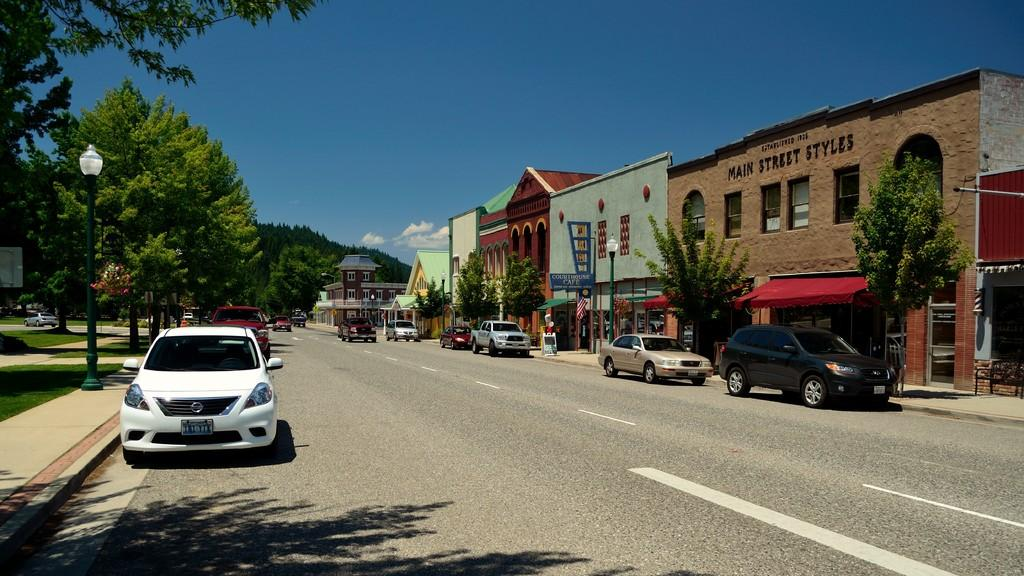What can be seen on the road in the image? There are vehicles on the road in the image. What type of natural elements are visible in the image? There are trees visible in the image. What type of man-made structures can be seen in the image? There are buildings in the image. What is visible in the sky in the image? Clouds are present in the sky in the image. Can you hear the toad laughing in the image? There is no toad or laughter present in the image; it only contains vehicles, trees, buildings, and clouds. 